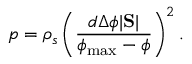<formula> <loc_0><loc_0><loc_500><loc_500>p = \rho _ { s } \left ( \frac { d \Delta \phi | S | } { \phi _ { \max } - \phi } \right ) ^ { 2 } .</formula> 